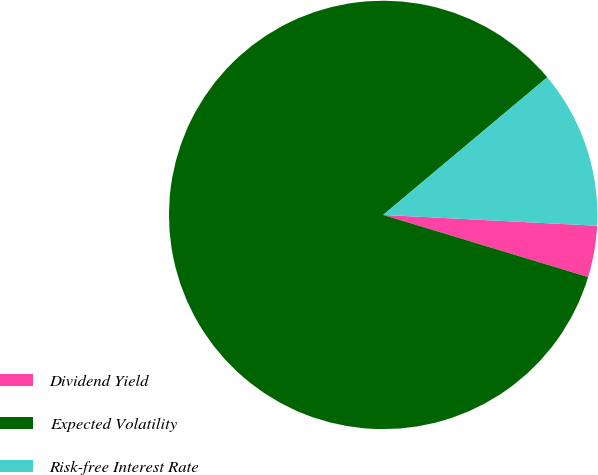Convert chart to OTSL. <chart><loc_0><loc_0><loc_500><loc_500><pie_chart><fcel>Dividend Yield<fcel>Expected Volatility<fcel>Risk-free Interest Rate<nl><fcel>3.88%<fcel>84.21%<fcel>11.91%<nl></chart> 